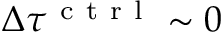<formula> <loc_0><loc_0><loc_500><loc_500>\Delta \tau ^ { c t r l } \sim 0</formula> 